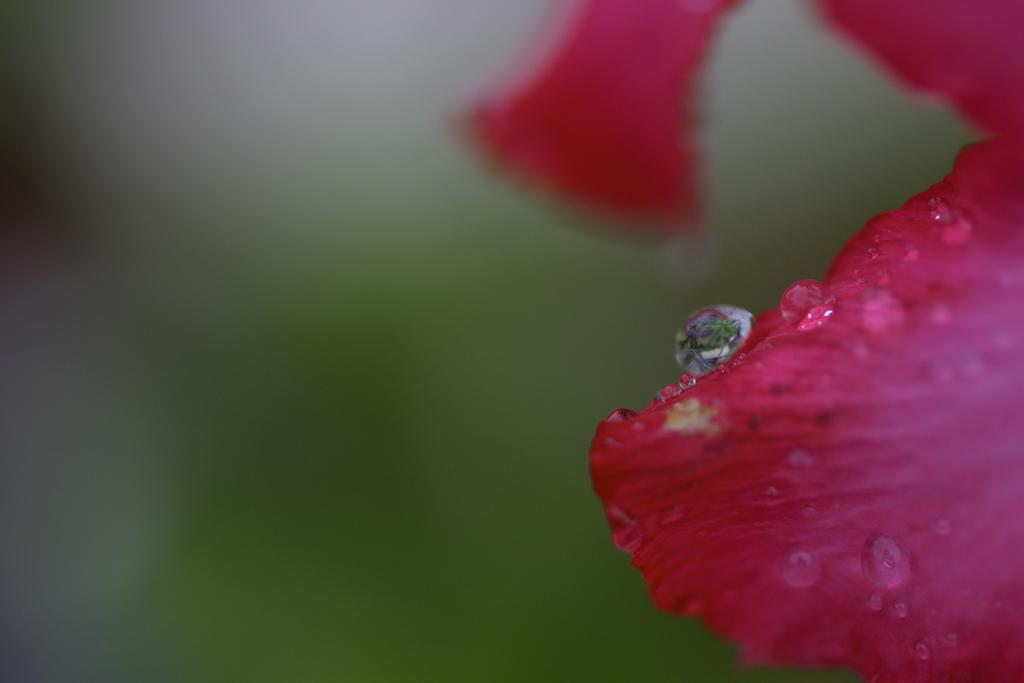What is the main subject of the image? The main subject of the image is a flower petal. What can be seen on the flower petal? Water droplets are visible on the flower petal. How would you describe the background of the image? The background of the image is blurred. What order is the flower petal following in the image? There is no order being followed by the flower petal in the image. What is the cause of the water droplets on the flower petal? The cause of the water droplets on the flower petal is not mentioned in the image. 